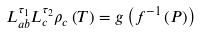Convert formula to latex. <formula><loc_0><loc_0><loc_500><loc_500>L _ { a b } ^ { \tau _ { 1 } } L _ { c } ^ { \tau _ { 2 } } \rho _ { c } \left ( T \right ) = g \left ( f ^ { - 1 } \left ( P \right ) \right )</formula> 